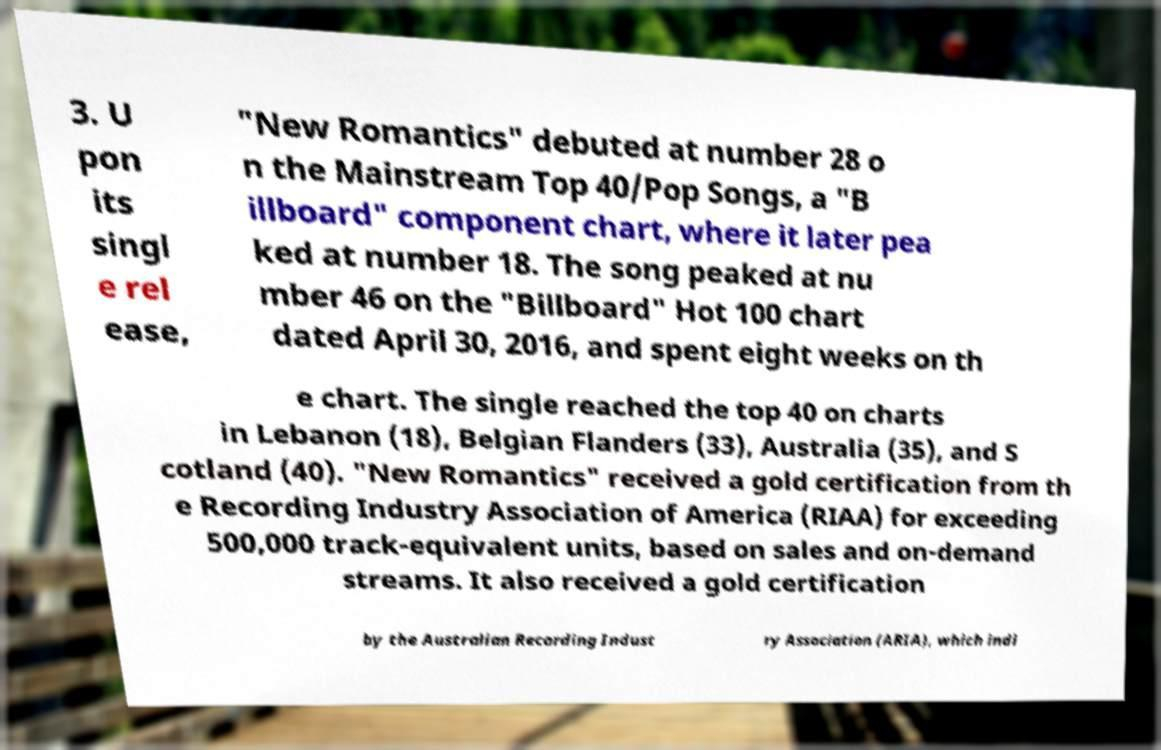Please read and relay the text visible in this image. What does it say? 3. U pon its singl e rel ease, "New Romantics" debuted at number 28 o n the Mainstream Top 40/Pop Songs, a "B illboard" component chart, where it later pea ked at number 18. The song peaked at nu mber 46 on the "Billboard" Hot 100 chart dated April 30, 2016, and spent eight weeks on th e chart. The single reached the top 40 on charts in Lebanon (18), Belgian Flanders (33), Australia (35), and S cotland (40). "New Romantics" received a gold certification from th e Recording Industry Association of America (RIAA) for exceeding 500,000 track-equivalent units, based on sales and on-demand streams. It also received a gold certification by the Australian Recording Indust ry Association (ARIA), which indi 